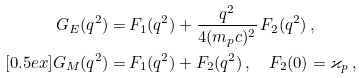Convert formula to latex. <formula><loc_0><loc_0><loc_500><loc_500>G _ { E } ( q ^ { 2 } ) = & \, F _ { 1 } ( q ^ { 2 } ) + \frac { q ^ { 2 } } { 4 ( m _ { p } c ) ^ { 2 } } \, F _ { 2 } ( q ^ { 2 } ) \, , \\ [ 0 . 5 e x ] G _ { M } ( q ^ { 2 } ) = & \, F _ { 1 } ( q ^ { 2 } ) + F _ { 2 } ( q ^ { 2 } ) \, , \quad F _ { 2 } ( 0 ) = \varkappa _ { p } \, ,</formula> 